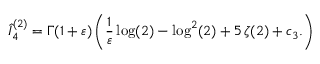Convert formula to latex. <formula><loc_0><loc_0><loc_500><loc_500>\hat { I } _ { 4 } ^ { ( 2 ) } = \Gamma ( 1 + \varepsilon ) \left ( \frac { 1 } { \varepsilon } \log ( 2 ) - \log ^ { 2 } ( 2 ) + 5 \, \zeta ( 2 ) + c _ { 3 } . \right )</formula> 